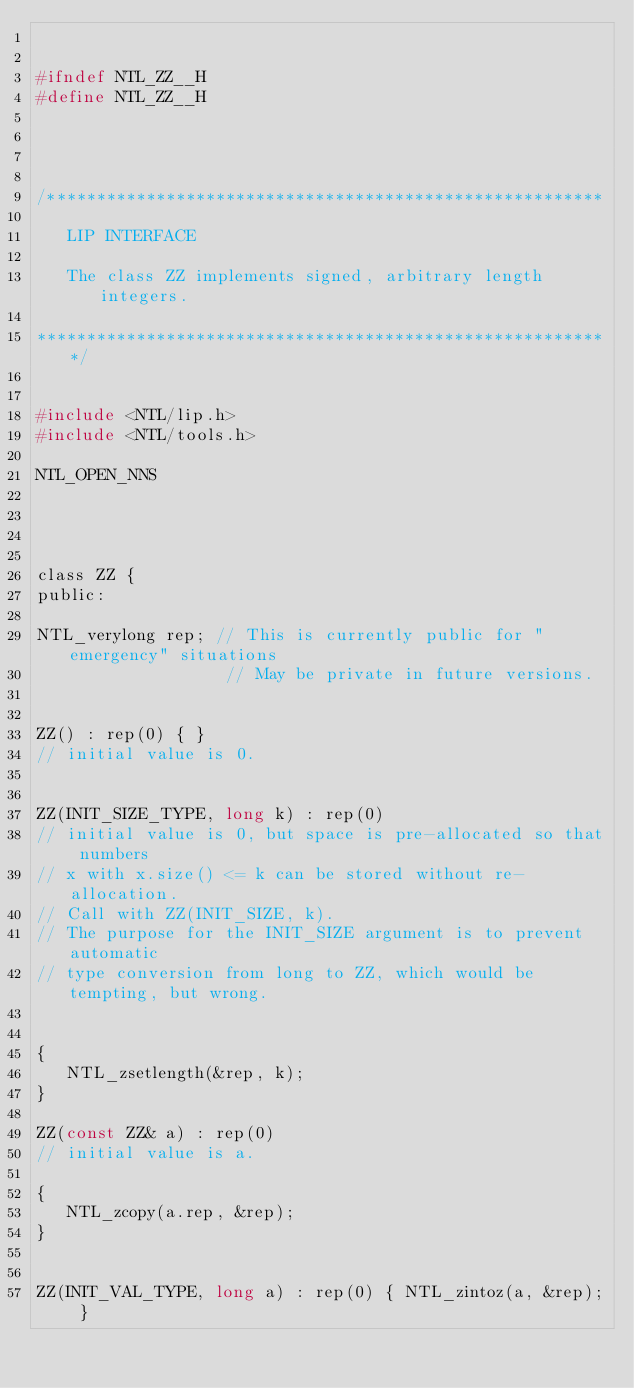<code> <loc_0><loc_0><loc_500><loc_500><_C_>

#ifndef NTL_ZZ__H
#define NTL_ZZ__H




/********************************************************

   LIP INTERFACE 

   The class ZZ implements signed, arbitrary length integers.

**********************************************************/


#include <NTL/lip.h>
#include <NTL/tools.h>

NTL_OPEN_NNS




class ZZ {
public:

NTL_verylong rep; // This is currently public for "emergency" situations
                   // May be private in future versions.


ZZ() : rep(0) { }
// initial value is 0.


ZZ(INIT_SIZE_TYPE, long k) : rep(0)
// initial value is 0, but space is pre-allocated so that numbers
// x with x.size() <= k can be stored without re-allocation.
// Call with ZZ(INIT_SIZE, k).
// The purpose for the INIT_SIZE argument is to prevent automatic
// type conversion from long to ZZ, which would be tempting, but wrong.


{
   NTL_zsetlength(&rep, k); 
}

ZZ(const ZZ& a) : rep(0)
// initial value is a.

{
   NTL_zcopy(a.rep, &rep);
}


ZZ(INIT_VAL_TYPE, long a) : rep(0) { NTL_zintoz(a, &rep); }</code> 